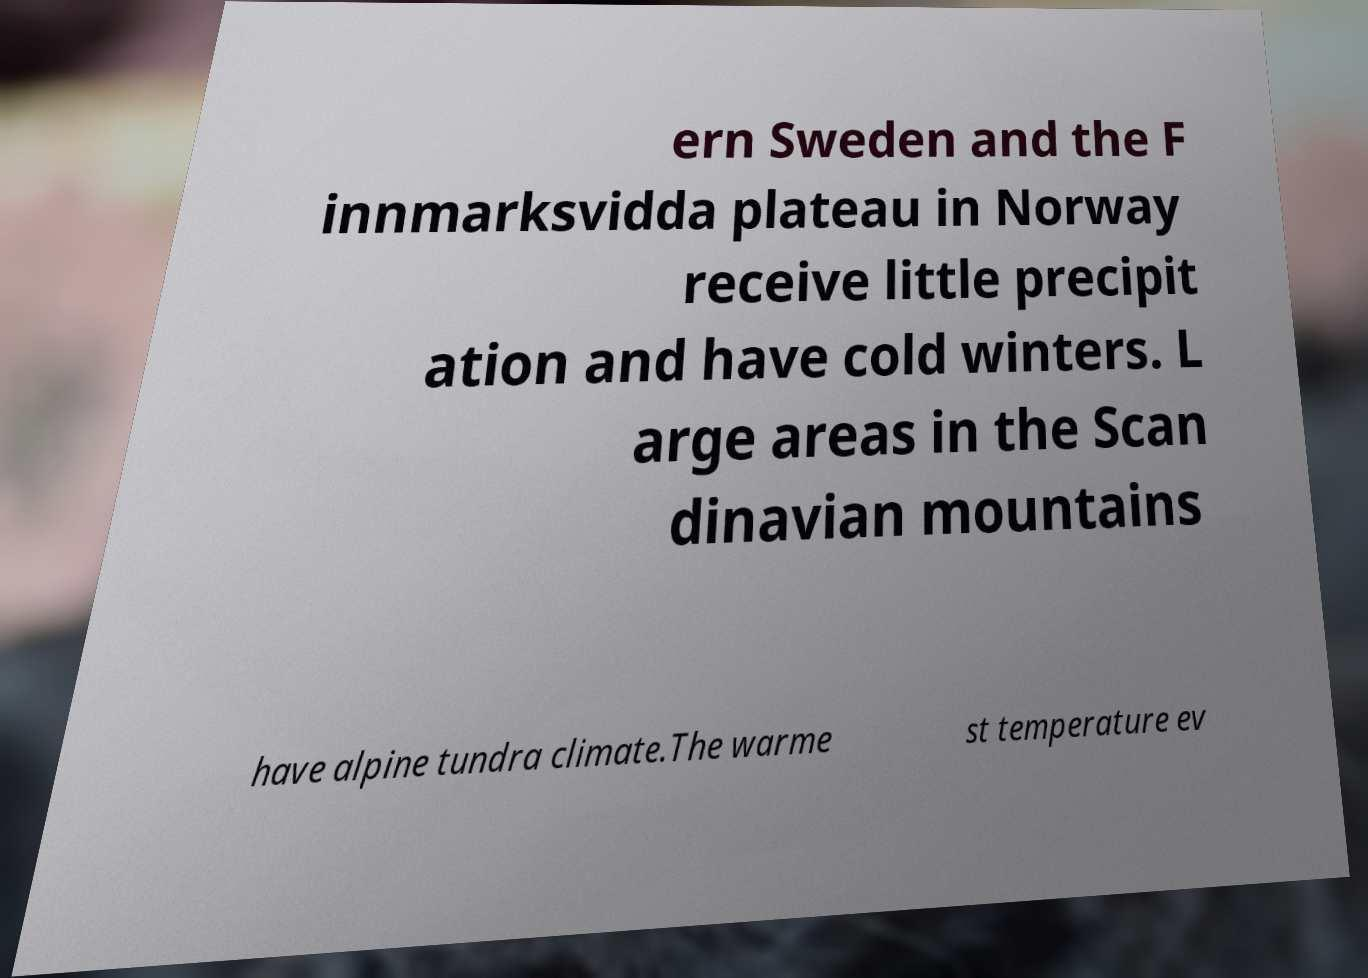For documentation purposes, I need the text within this image transcribed. Could you provide that? ern Sweden and the F innmarksvidda plateau in Norway receive little precipit ation and have cold winters. L arge areas in the Scan dinavian mountains have alpine tundra climate.The warme st temperature ev 